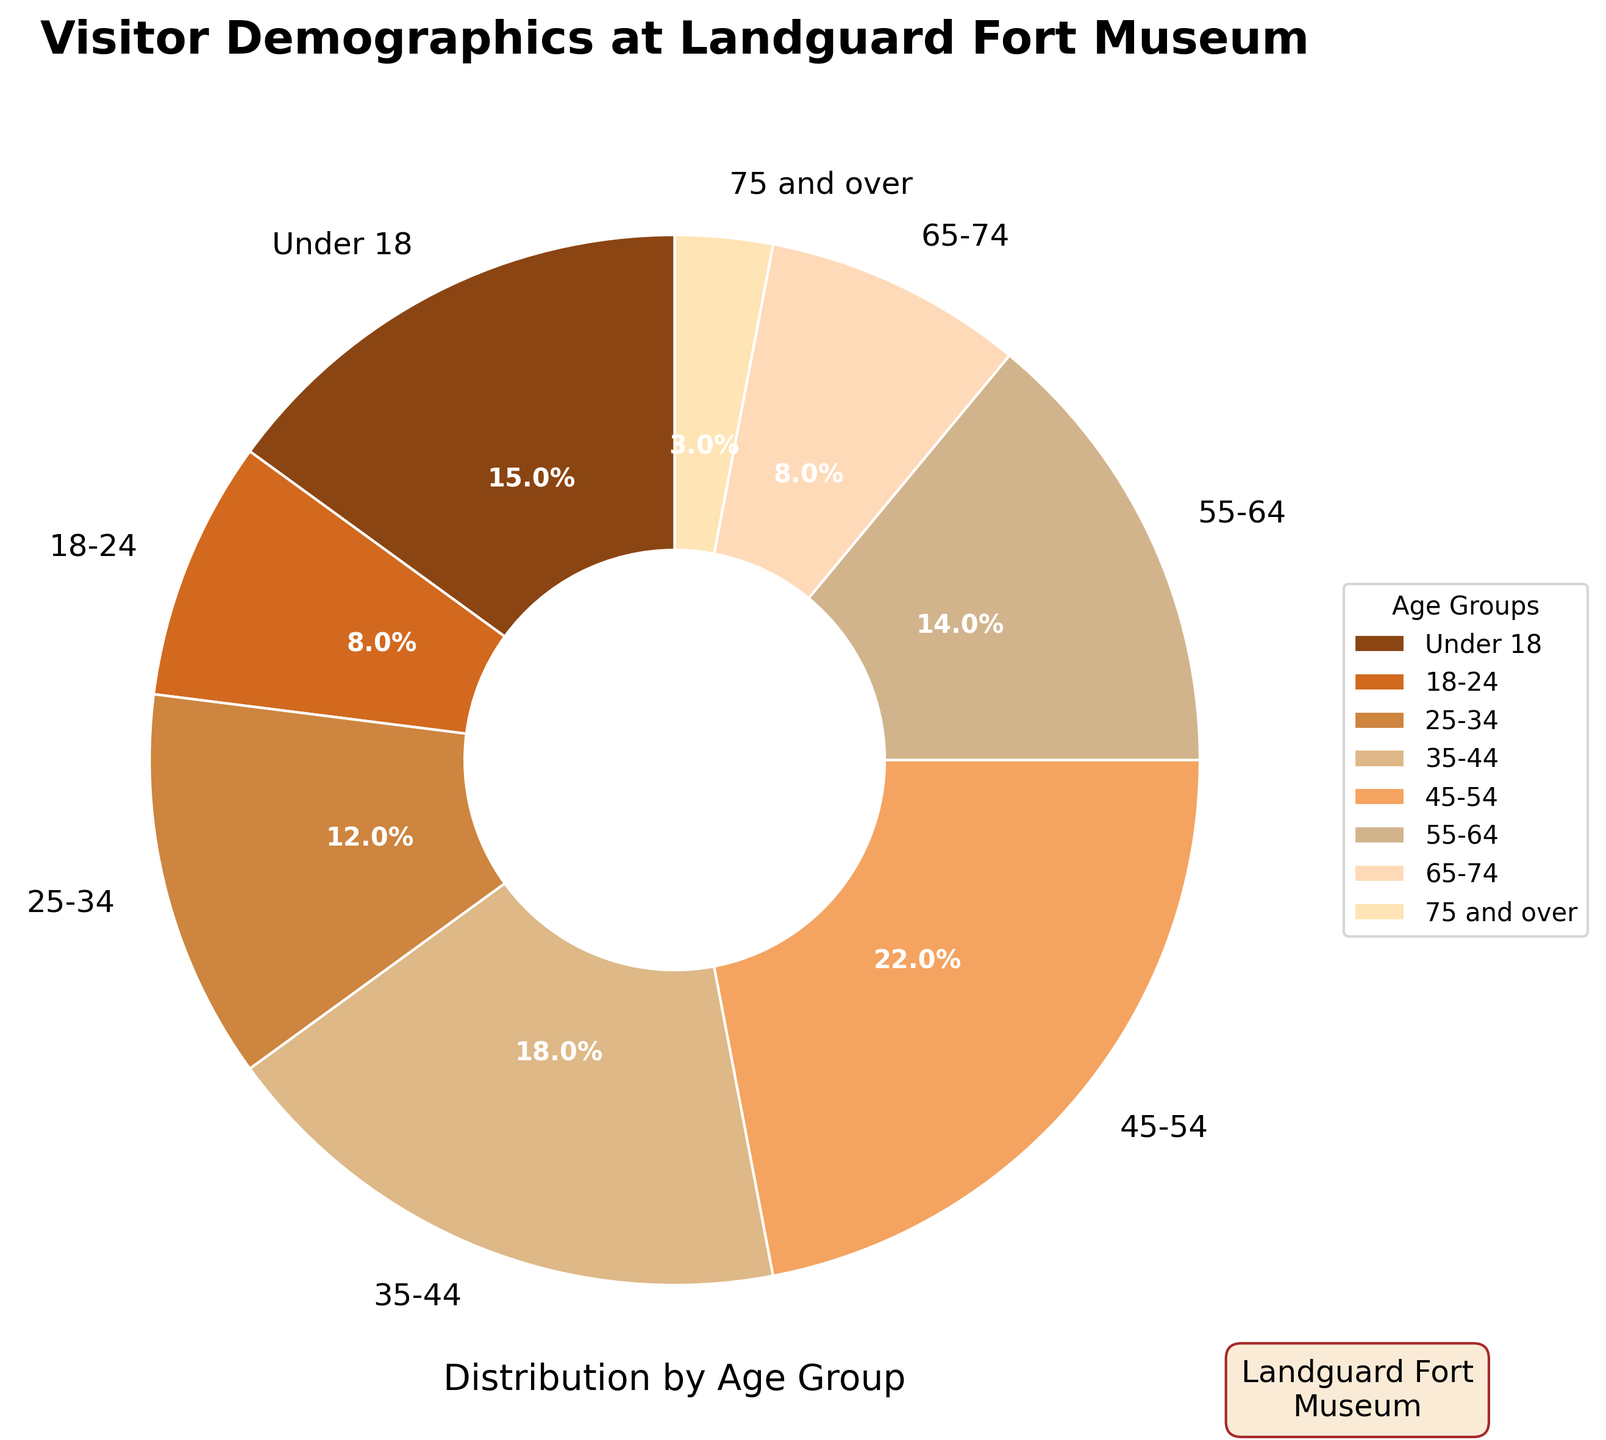Which age group has the highest percentage of visitors? The slice with the largest area represents the 45-54 age group, which has the highest percentage.
Answer: 45-54 What is the combined percentage of visitors aged 18-24 and 65-74? Adding the percentages for the 18-24 group (8%) and 65-74 group (8%) gives 8 + 8 = 16
Answer: 16 How does the percentage of visitors aged 55-64 compare to that of visitors aged 25-34? The percentage of the 55-64 group (14%) is greater than the 25-34 group (12%).
Answer: 55-64 > 25-34 Which age group has the lowest percentage of visitors? The smallest slice represents visitors aged 75 and over, with 3%.
Answer: 75 and over What is the total percentage of visitors under the age of 25? Adding the percentages for under 18 (15%) and 18-24 (8%) gives 15 + 8 = 23
Answer: 23 Compare the combined percentage of age groups 35-44 and 45-54 to the combined percentage of age groups 25-34 and 55-64. Adding 35-44 (18%) and 45-54 (22%) gives 40. Adding 25-34 (12%) and 55-64 (14%) gives 26. Therefore, 40 is greater than 26.
Answer: 40 > 26 What fraction of the visitors are 55 and older? Adding the percentages for 55-64 (14%), 65-74 (8%), and 75 and over (3%) gives 14 + 8 + 3 = 25
Answer: 25% How does the percentage of visitors aged under 18 compare to the combined percentage of visitors aged 18-24 and 25-34? Adding the percentages for 18-24 (8%) and 25-34 (12%) gives 20, which is greater than the percentage for under 18 (15%).
Answer: Under 18 < 18-24 + 25-34 